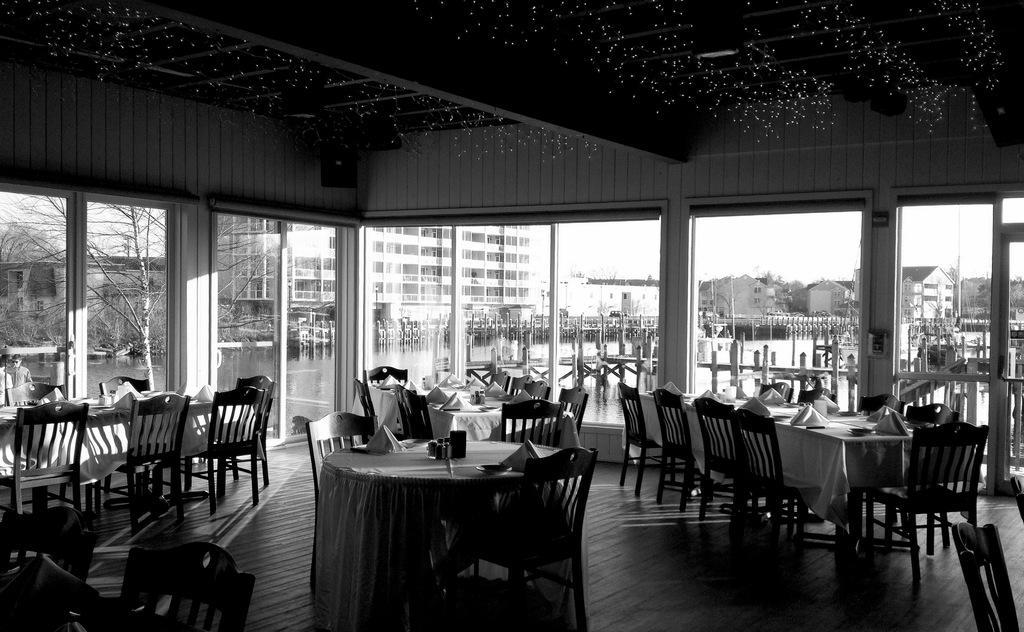Describe this image in one or two sentences. As we can see in the image there are buildings, chairs, tables and trees in the background. On tables there are white color clothes. On the top there is sky. 